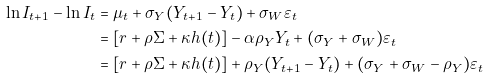Convert formula to latex. <formula><loc_0><loc_0><loc_500><loc_500>\ln I _ { t + 1 } - \ln I _ { t } & = { \mu } _ { t } + \sigma _ { Y } ( Y _ { t + 1 } - Y _ { t } ) + \sigma _ { W } \varepsilon _ { t } \\ & = [ r + \rho \Sigma + \kappa h ( t ) ] - \alpha \rho _ { Y } Y _ { t } + ( \sigma _ { Y } + \sigma _ { W } ) \varepsilon _ { t } \\ & = [ r + \rho \Sigma + \kappa h ( t ) ] + \rho _ { Y } ( Y _ { t + 1 } - Y _ { t } ) + ( \sigma _ { Y } + \sigma _ { W } - \rho _ { Y } ) \varepsilon _ { t }</formula> 